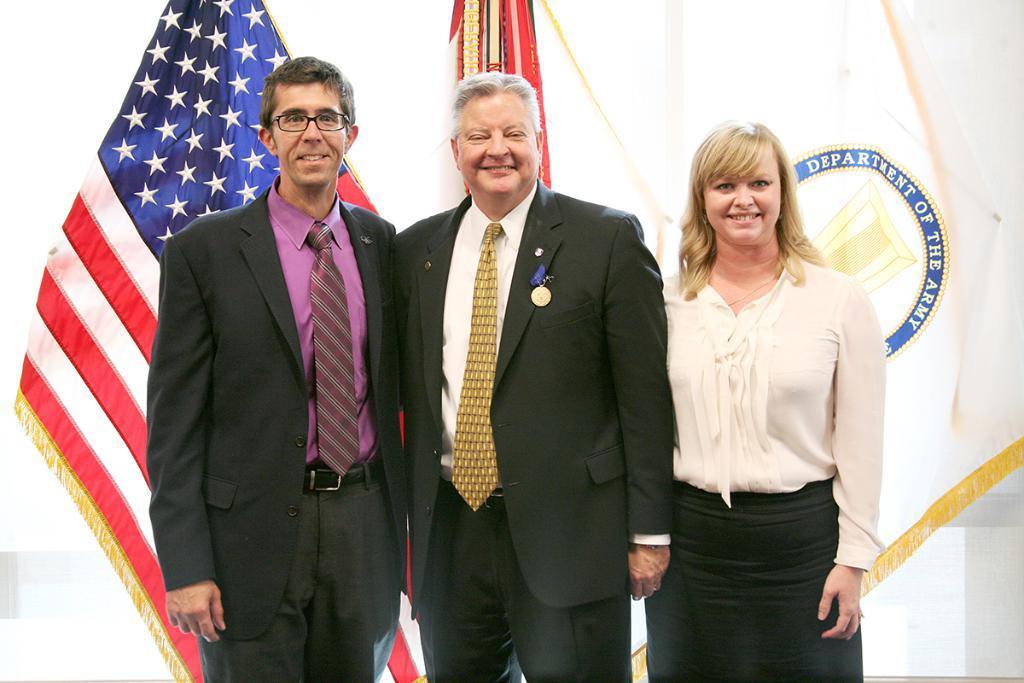Describe this image in one or two sentences. In this picture we can see there are three people standing and behind the people there are flags. 